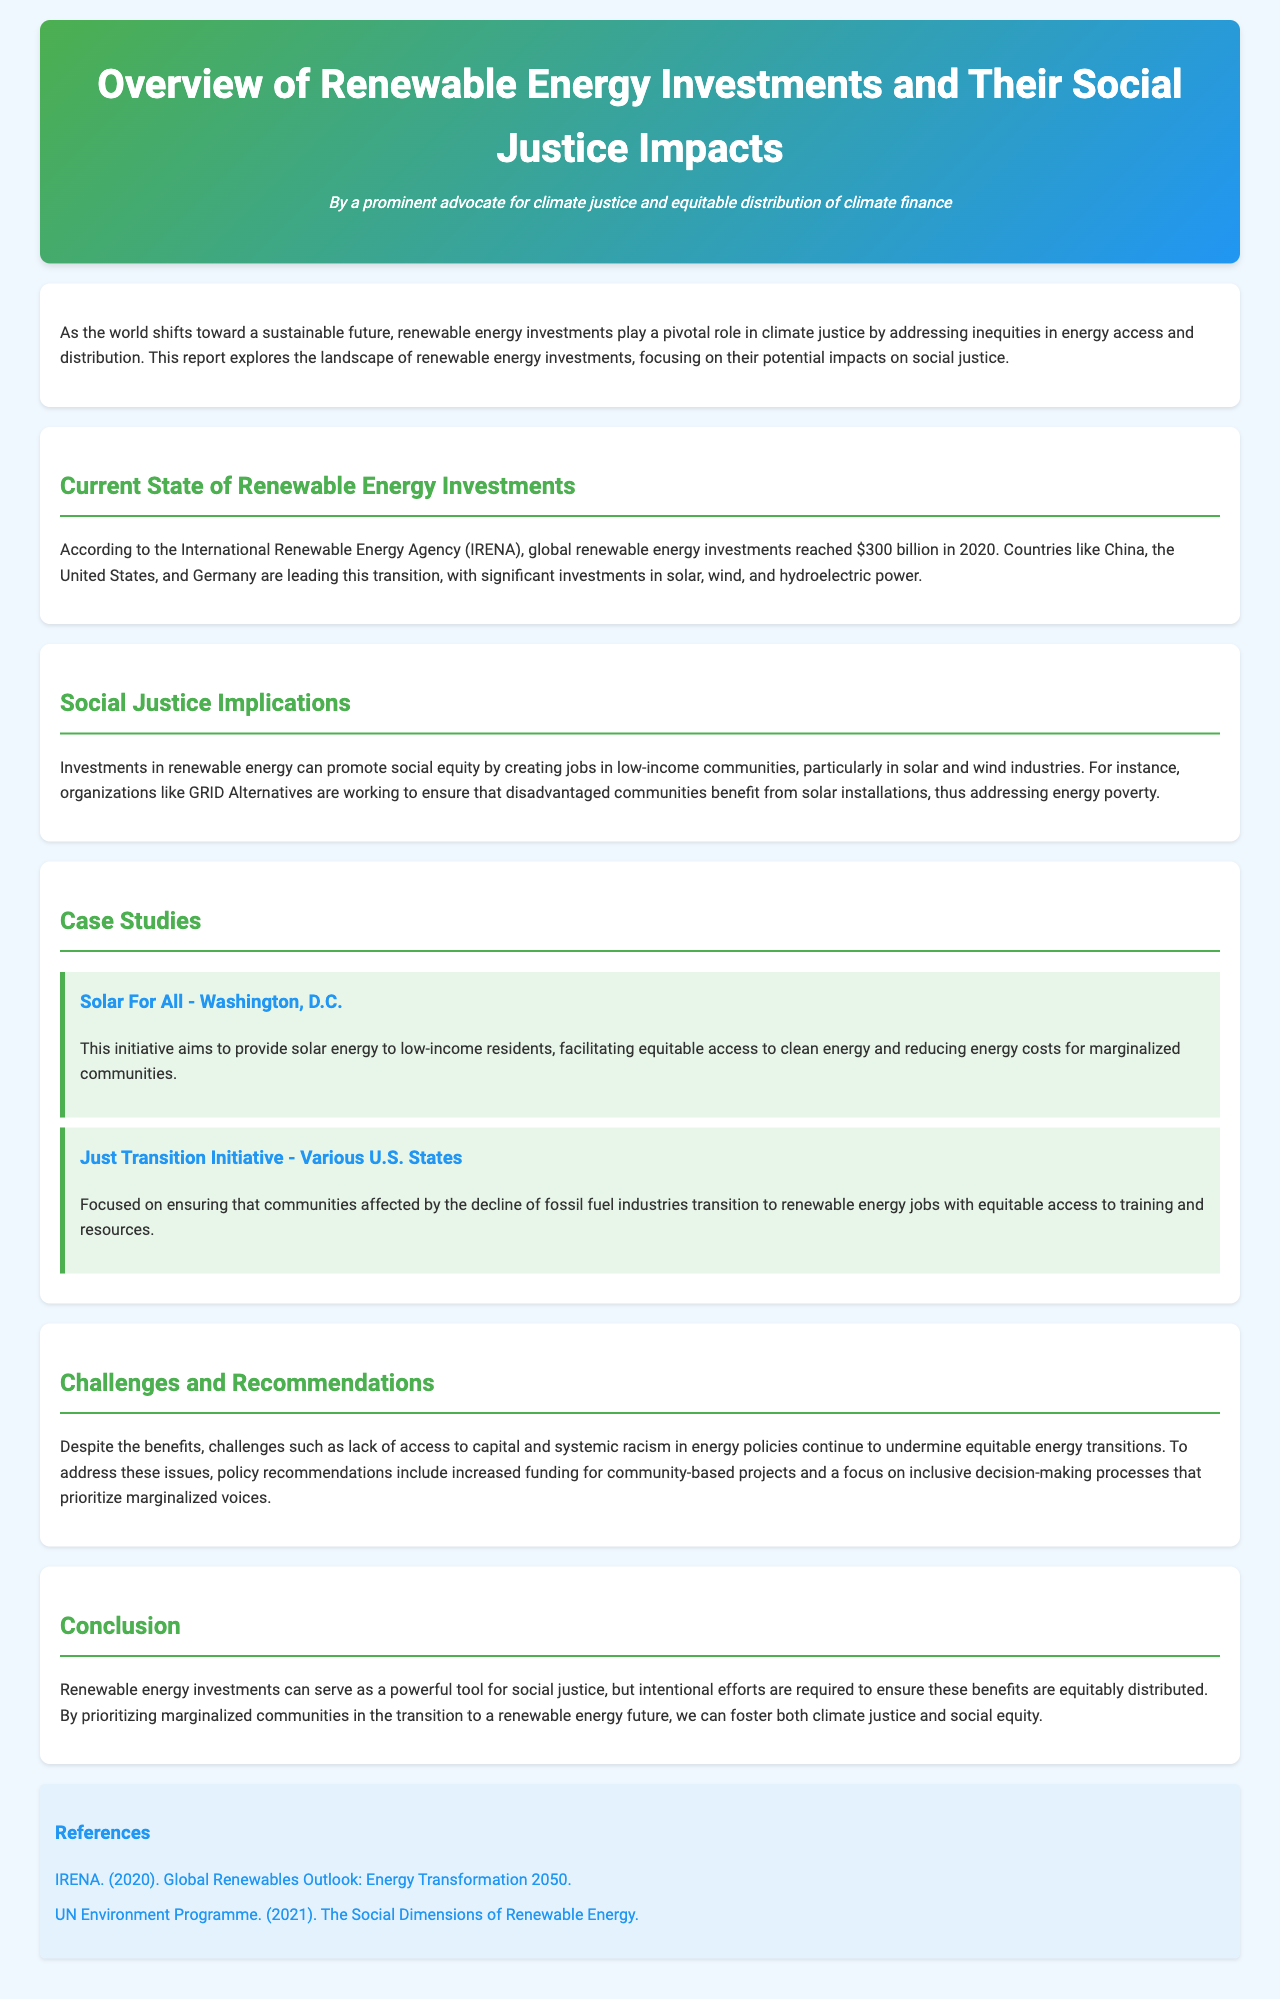What was the global renewable energy investment in 2020? The document states that global renewable energy investments reached $300 billion in 2020.
Answer: $300 billion Which countries are leading in renewable energy investments? The report mentions that China, the United States, and Germany are leading this transition in renewable energy investments.
Answer: China, United States, Germany What is the focus of organizations like GRID Alternatives? The report indicates that organizations like GRID Alternatives are working to ensure that disadvantaged communities benefit from solar installations.
Answer: Disadvantaged communities What initiative aims to provide solar energy to low-income residents? The Solar For All initiative in Washington, D.C. aims to provide solar energy to low-income residents.
Answer: Solar For All What challenges are mentioned regarding renewable energy investments? The report highlights lack of access to capital and systemic racism in energy policies as challenges undermining equitable energy transitions.
Answer: Lack of access to capital, systemic racism What is one of the policy recommendations for equitable energy transitions? The document suggests increased funding for community-based projects as a policy recommendation.
Answer: Increased funding for community-based projects What type of investments can serve as a tool for social justice? The report states that renewable energy investments can serve as a powerful tool for social justice.
Answer: Renewable energy investments In what year did IRENA publish the Global Renewables Outlook? IRENA published the Global Renewables Outlook in 2020.
Answer: 2020 